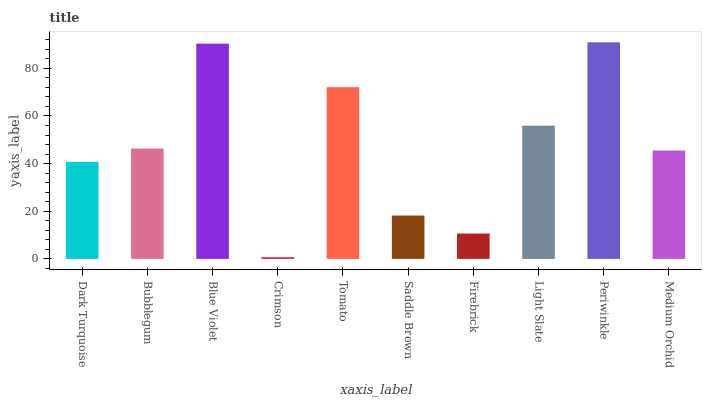Is Crimson the minimum?
Answer yes or no. Yes. Is Periwinkle the maximum?
Answer yes or no. Yes. Is Bubblegum the minimum?
Answer yes or no. No. Is Bubblegum the maximum?
Answer yes or no. No. Is Bubblegum greater than Dark Turquoise?
Answer yes or no. Yes. Is Dark Turquoise less than Bubblegum?
Answer yes or no. Yes. Is Dark Turquoise greater than Bubblegum?
Answer yes or no. No. Is Bubblegum less than Dark Turquoise?
Answer yes or no. No. Is Bubblegum the high median?
Answer yes or no. Yes. Is Medium Orchid the low median?
Answer yes or no. Yes. Is Light Slate the high median?
Answer yes or no. No. Is Crimson the low median?
Answer yes or no. No. 